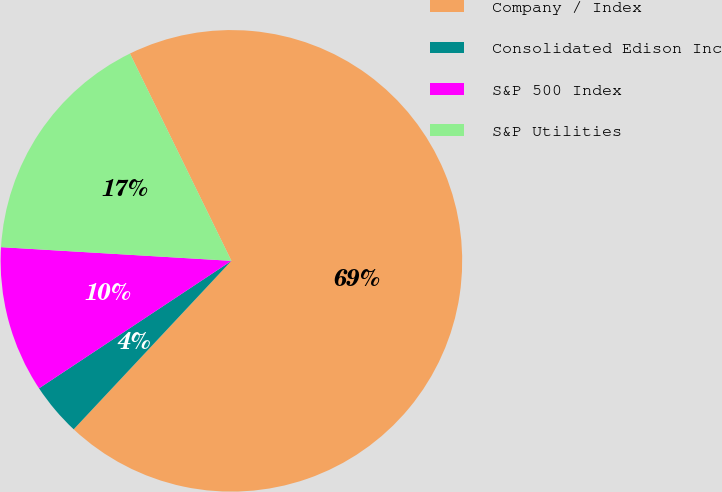Convert chart. <chart><loc_0><loc_0><loc_500><loc_500><pie_chart><fcel>Company / Index<fcel>Consolidated Edison Inc<fcel>S&P 500 Index<fcel>S&P Utilities<nl><fcel>69.23%<fcel>3.71%<fcel>10.26%<fcel>16.81%<nl></chart> 